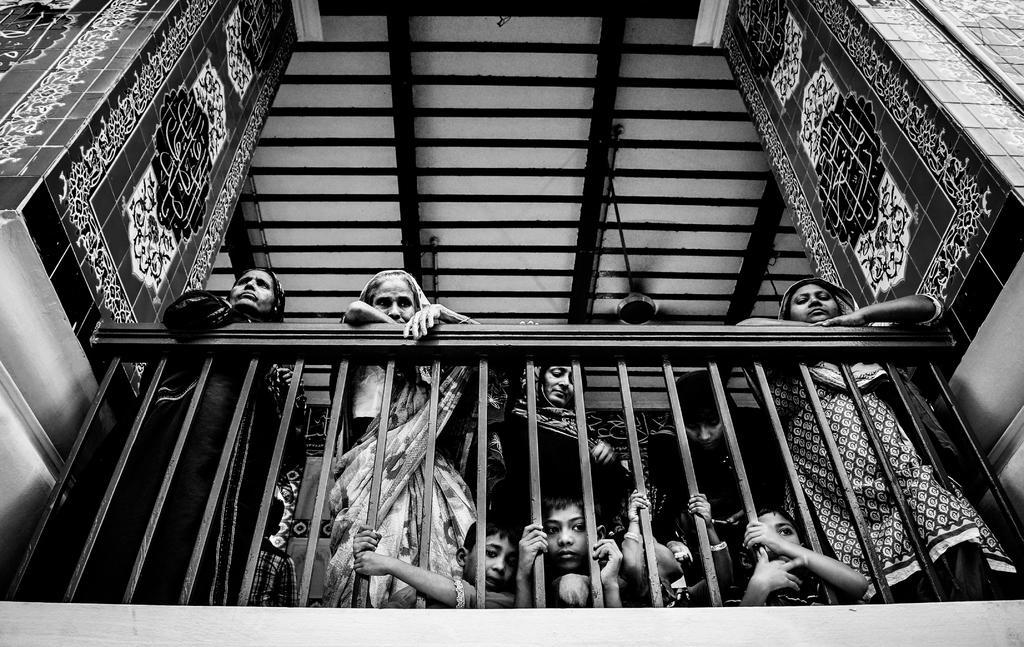Please provide a concise description of this image. In this picture I can see there are few people standing here at the railing and there are two pillars here. Onto ceiling there is a fan attached. 